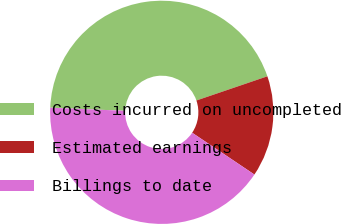Convert chart to OTSL. <chart><loc_0><loc_0><loc_500><loc_500><pie_chart><fcel>Costs incurred on uncompleted<fcel>Estimated earnings<fcel>Billings to date<nl><fcel>44.11%<fcel>14.64%<fcel>41.25%<nl></chart> 